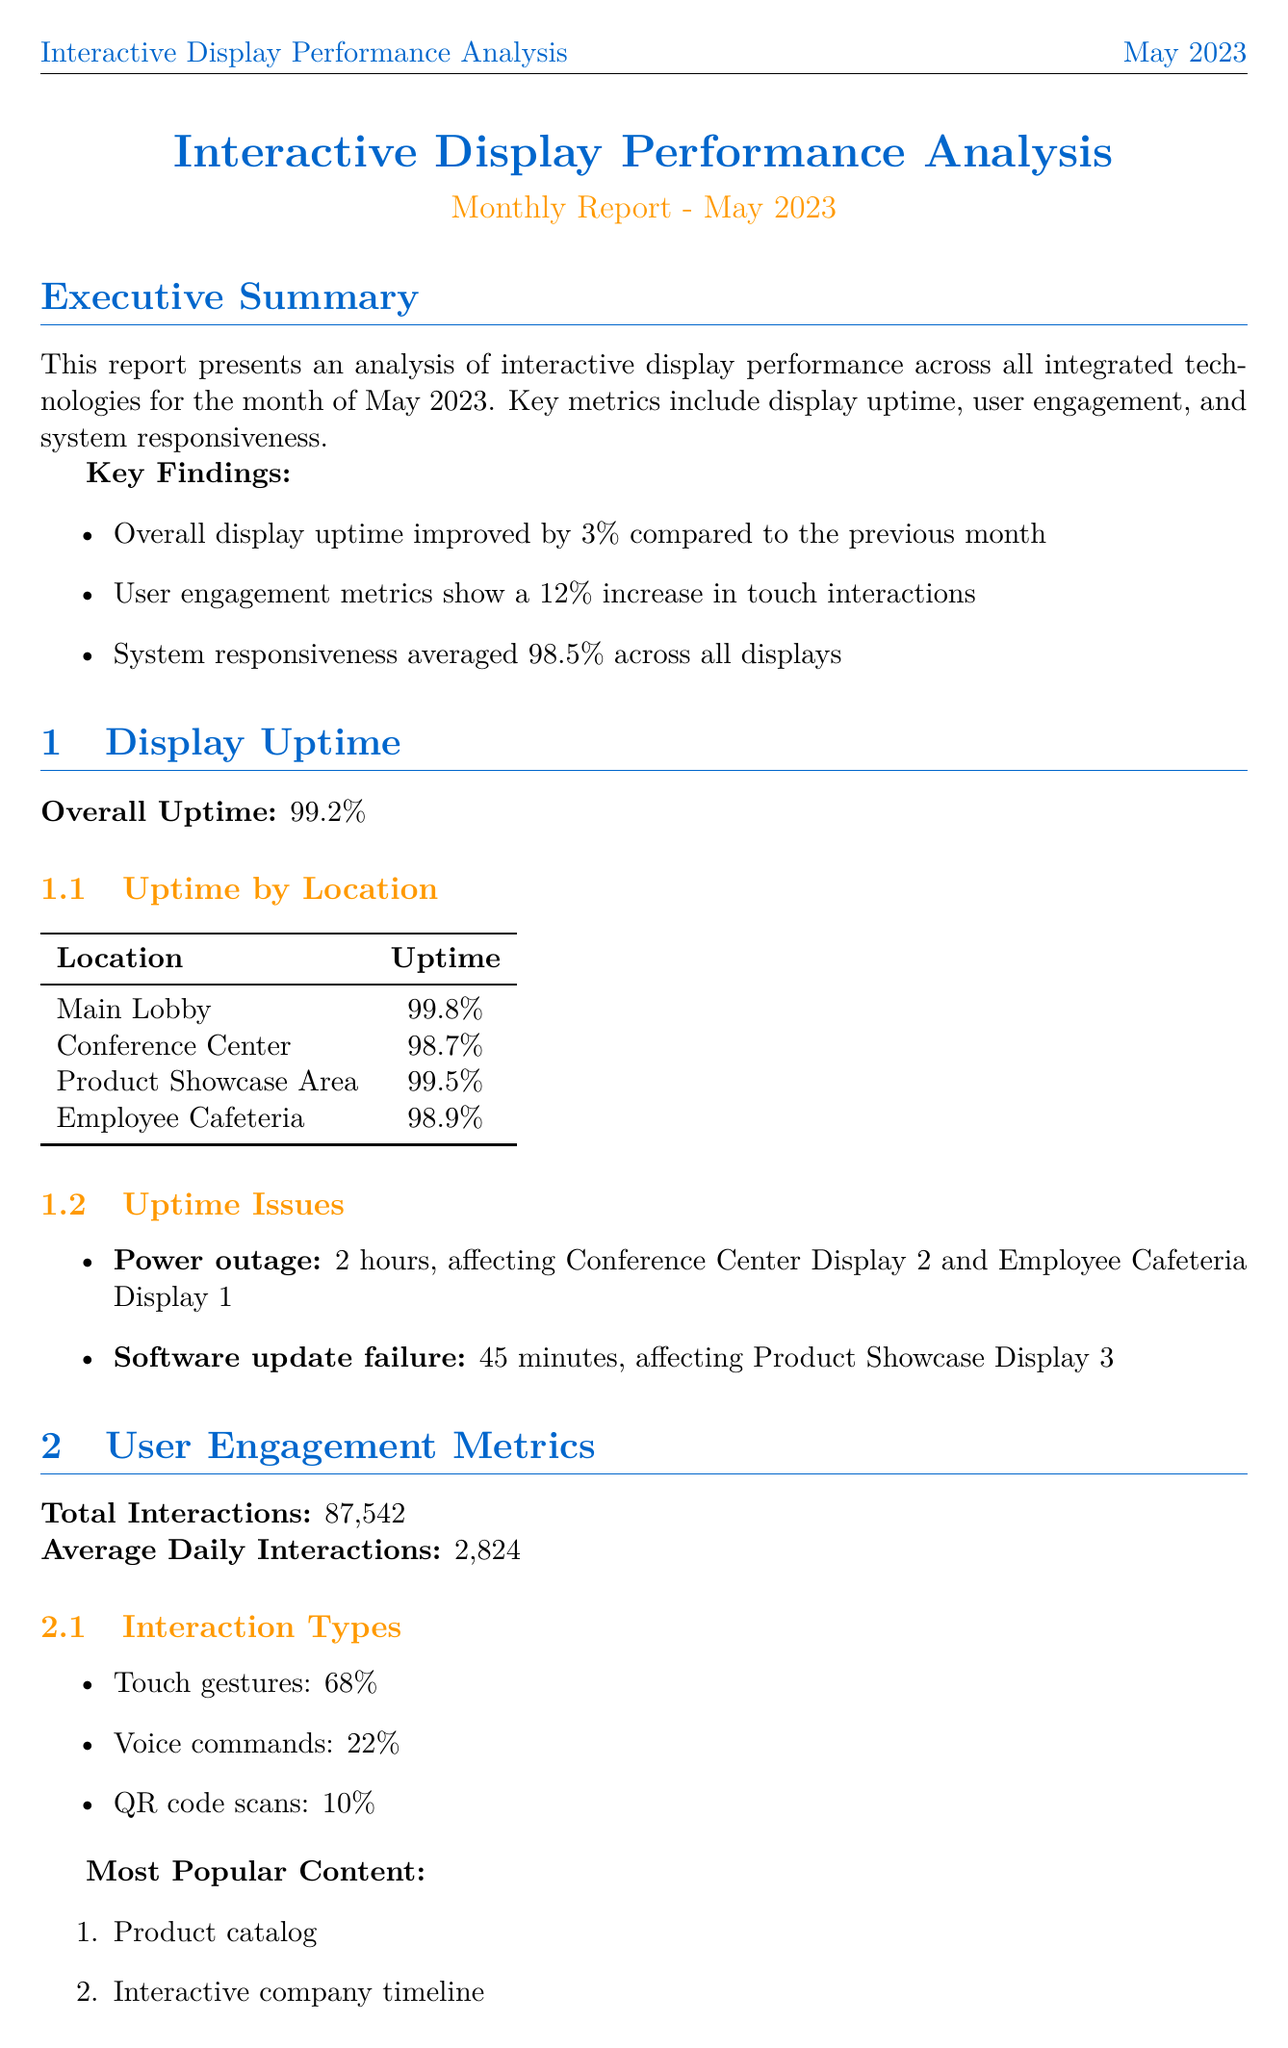What is the overall uptime of the displays? The overall uptime is stated in the document as the overall performance of the displays for the month of May 2023.
Answer: 99.2% What was the user satisfaction score? The user satisfaction score is a specific metric included in the user engagement metrics section of the report.
Answer: 4.2 What percentage of interactions were touch gestures? The interaction types section outlines the distribution of different types of user interactions, specifically highlighting the percentage of touch gestures.
Answer: 68% What is the average response time for Samsung QM85R-B displays? This figure is listed under the response time by display type, indicating the performance of specific display models.
Answer: 0.2 seconds What uptime issue lasted for 45 minutes? The uptime issues section describes specific problems that affected display functionality and their durations.
Answer: Software update failure What is the average speed of network connectivity? The network connectivity performance section provides insights into the average speed established for the system’s network.
Answer: 986 Mbps When was the last calibration of the touch sensors? The calibration status section specifies the date of the last calibration of the touch sensors to maintain their accuracy.
Answer: May 15, 2023 What upgrade is recommended for the voice recognition software? The recommendations section includes suggested improvements for integrated technologies, specifically the voice recognition software.
Answer: Improve multilingual support What is the total number of interactions recorded? The total interactions figure is provided in the user engagement metrics section, highlighting the volume of user engagement across all displays.
Answer: 87,542 